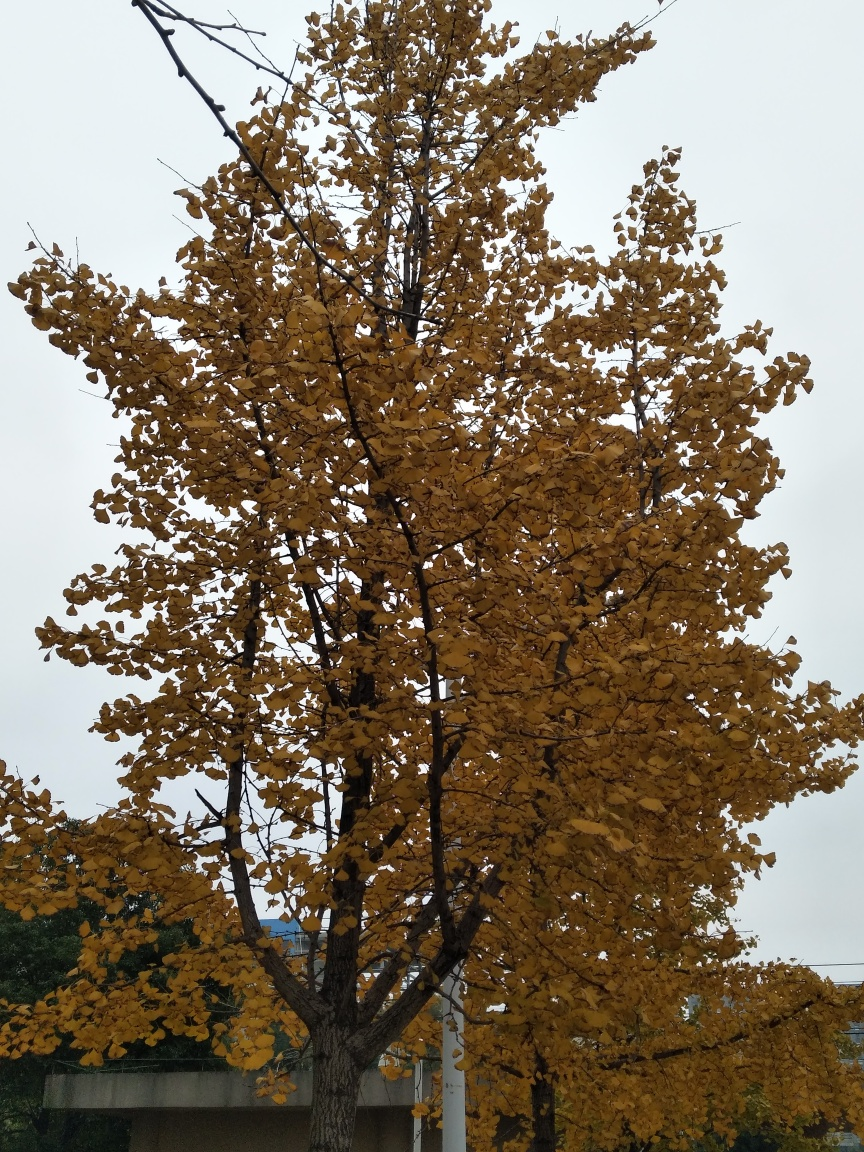What might be the significance of this single tree's portrayal? This single tree may symbolize resilience or solidarity. Standing firmly against the sky, it could represent the enduring power of nature or the beauty in standing out. In a symbolic sense, a solitary tree can be seen as a metaphor for individuality, strength, or the cycle of life amidst constant change. Considering its position and surroundings, what might be behind this tree? Based on its position, the tree seems to be situated in a public space or near a structure, hinted by the building visible in the background. It may be part of an urban park or positioned in front of an institutional or residential building, suggesting a landscaped area within a human-made environment. 